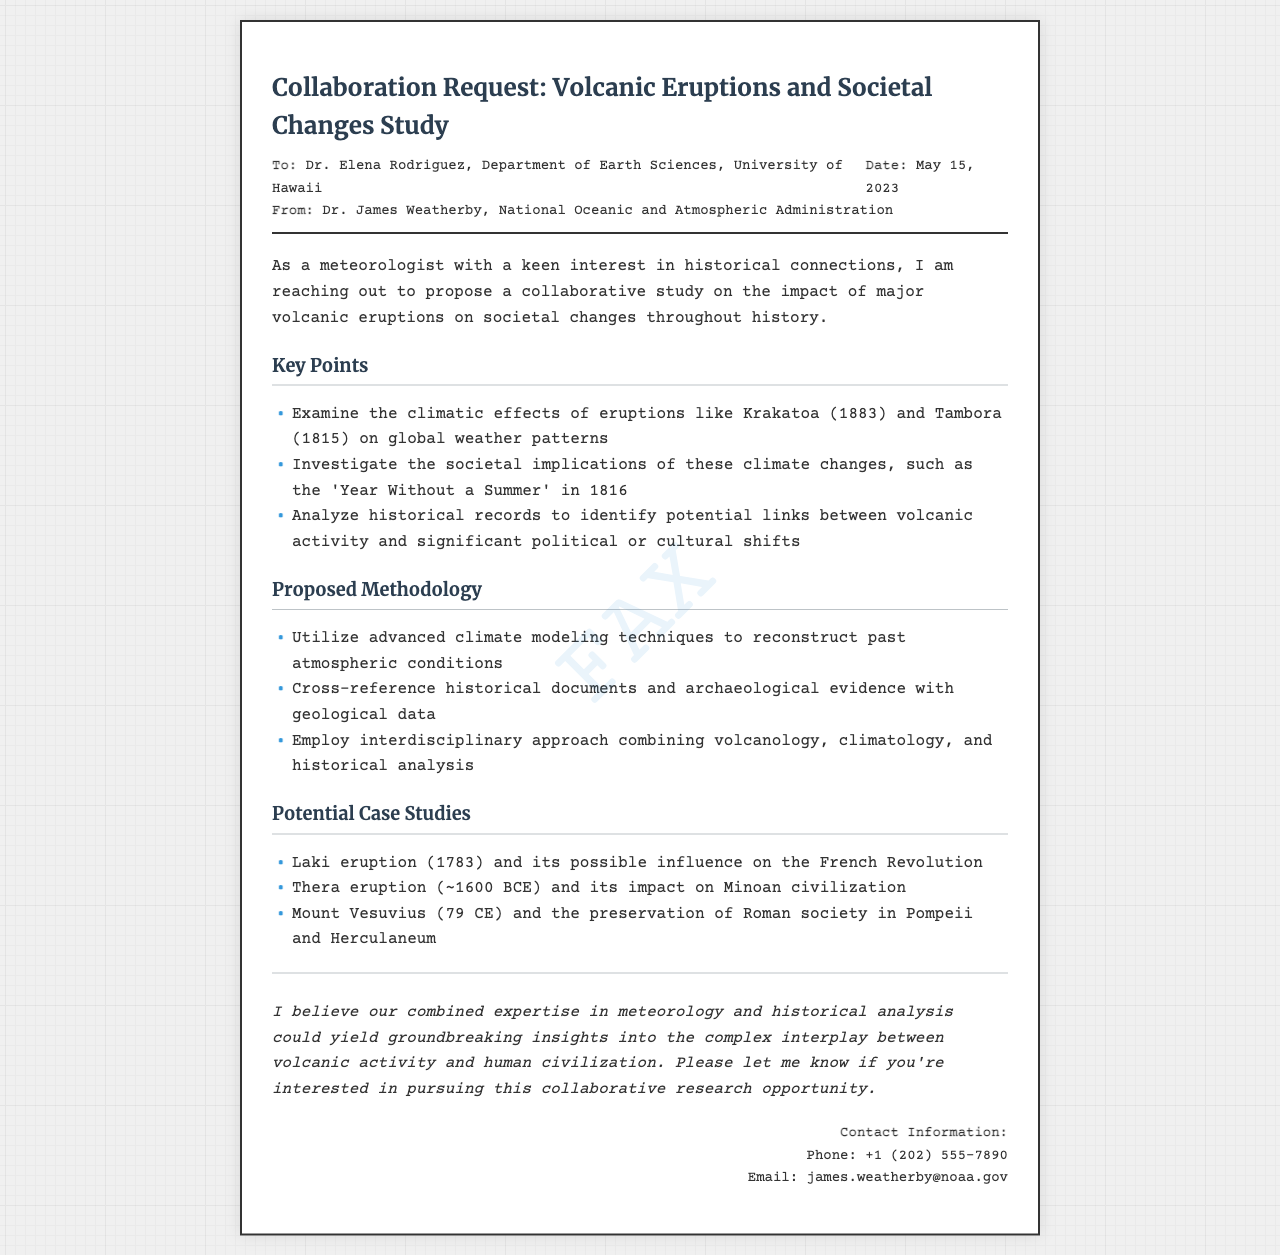What is the title of the fax? The title is mentioned at the top of the document, indicating the subject matter of the request.
Answer: Collaboration Request: Volcanic Eruptions and Societal Changes Study Who is the recipient of the fax? The recipient's name and affiliation are listed at the top of the document.
Answer: Dr. Elena Rodriguez, Department of Earth Sciences, University of Hawaii When was the fax sent? The date of the fax is situated near the header details.
Answer: May 15, 2023 What is one proposed case study? A specific example of a case study is provided in the document for investigation.
Answer: Laki eruption (1783) and its possible influence on the French Revolution Which two fields does the proposed collaborative study combine? The document outlines the interdisciplinary approach which includes these fields.
Answer: Volcanology, climatology What is the main purpose of the fax? The initial paragraph explains the primary goal of the communication.
Answer: To propose a collaborative study Who is the sender of the fax? The sender's name and affiliation are noted in the header section of the document.
Answer: Dr. James Weatherby, National Oceanic and Atmospheric Administration What is the contact phone number provided? The contact information section includes a specific phone number for inquiries.
Answer: +1 (202) 555-7890 What climatic effect is linked to the Krakatoa eruption? This effect is indicated as part of the key points listed in the document.
Answer: Global weather patterns 